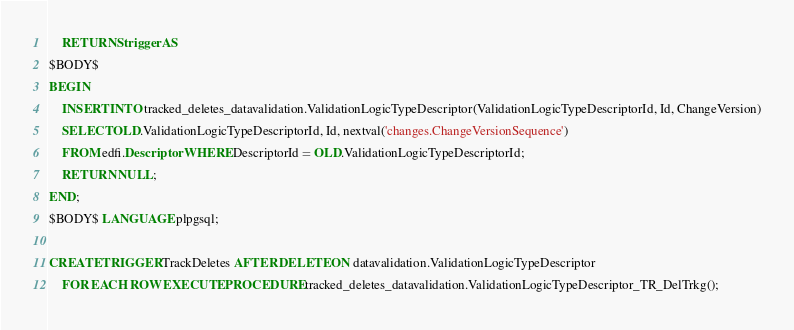<code> <loc_0><loc_0><loc_500><loc_500><_SQL_>    RETURNS trigger AS
$BODY$
BEGIN
    INSERT INTO tracked_deletes_datavalidation.ValidationLogicTypeDescriptor(ValidationLogicTypeDescriptorId, Id, ChangeVersion)
    SELECT OLD.ValidationLogicTypeDescriptorId, Id, nextval('changes.ChangeVersionSequence')
    FROM edfi.Descriptor WHERE DescriptorId = OLD.ValidationLogicTypeDescriptorId;
    RETURN NULL;
END;
$BODY$ LANGUAGE plpgsql;

CREATE TRIGGER TrackDeletes AFTER DELETE ON datavalidation.ValidationLogicTypeDescriptor 
    FOR EACH ROW EXECUTE PROCEDURE tracked_deletes_datavalidation.ValidationLogicTypeDescriptor_TR_DelTrkg();
</code> 